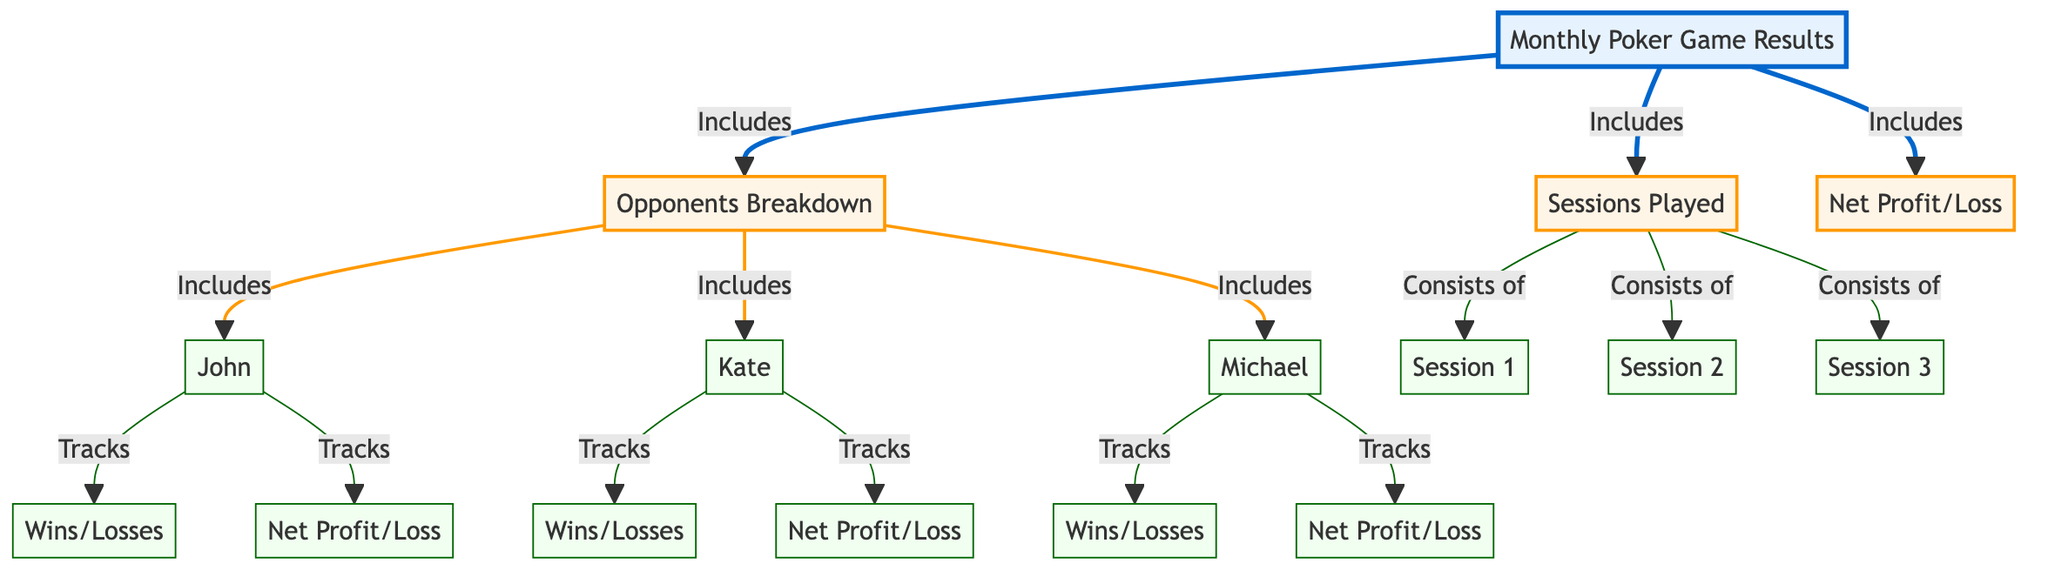What does the monthly results include? The diagram shows that "Monthly Poker Game Results" includes three key categories: "Opponents Breakdown," "Sessions Played," and "Net Profit/Loss." Each of these categories is represented as a sub-node connected to the monthly results node.
Answer: Opponents Breakdown, Sessions Played, Net Profit/Loss How many opponents are tracked in the breakdown? In the "Opponents Breakdown" section, there are three nodes representing opponents: "John," "Kate," and "Michael." This indicates that the breakdown details the results against these three players.
Answer: Three What sessions are included in the sessions played? The diagram specifies that "Sessions Played" consists of three sessions: "Session 1," "Session 2," and "Session 3." Each session is connected directly to the sessions played node, indicating they are part of the monthly results.
Answer: Session 1, Session 2, Session 3 Which opponent has net profit/loss tracked? Each opponent in the diagram has a corresponding net profit/loss tracked: "John," "Kate," and "Michael." Hence, the opponents are linked to their respective net profit/loss nodes.
Answer: John, Kate, Michael How do opponents track wins/losses? The diagram illustrates that each opponent node is linked to their own "Wins/Losses" node. This indicates that for each opponent—John, Kate, Michael—there is a specific tracking of the wins and losses.
Answer: By each opponent's Wins/Losses What is the relationship between opponents and their net profit/loss? According to the diagram, each opponent node ("John," "Kate," "Michael") has a direct link to their respective "Net Profit/Loss" node, establishing that each opponent's performance is accounted for in terms of net winnings or losses.
Answer: Each opponent has a direct link to their net profit/loss What kind of diagram is this? This is a flowchart that visually represents the relationships and data breakdown regarding monthly poker game results, detailing specific categories and connections between nodes.
Answer: Flowchart 